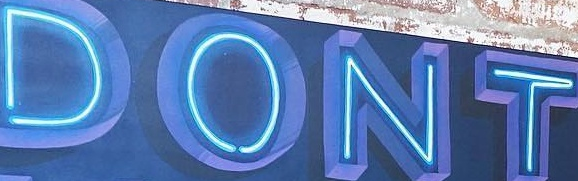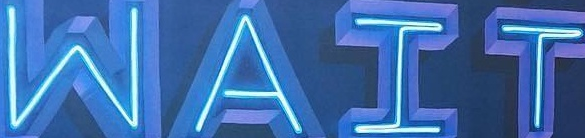Read the text content from these images in order, separated by a semicolon. DONT; WAIT 